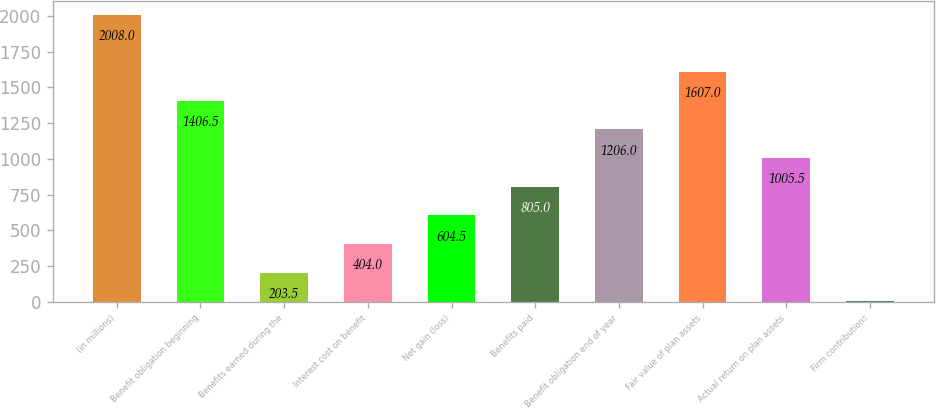Convert chart to OTSL. <chart><loc_0><loc_0><loc_500><loc_500><bar_chart><fcel>(in millions)<fcel>Benefit obligation beginning<fcel>Benefits earned during the<fcel>Interest cost on benefit<fcel>Net gain (loss)<fcel>Benefits paid<fcel>Benefit obligation end of year<fcel>Fair value of plan assets<fcel>Actual return on plan assets<fcel>Firm contributions<nl><fcel>2008<fcel>1406.5<fcel>203.5<fcel>404<fcel>604.5<fcel>805<fcel>1206<fcel>1607<fcel>1005.5<fcel>3<nl></chart> 